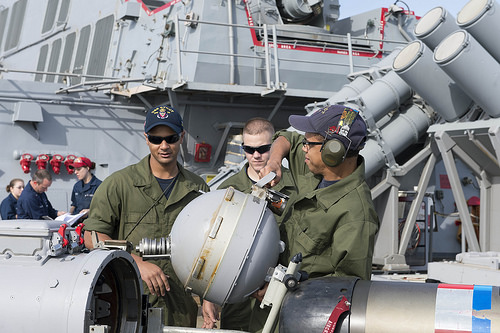<image>
Can you confirm if the man is in front of the hat? No. The man is not in front of the hat. The spatial positioning shows a different relationship between these objects. 